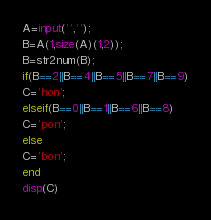Convert code to text. <code><loc_0><loc_0><loc_500><loc_500><_Octave_>A=input('','');
B=A(1,size(A)(1,2));
B=str2num(B);
if(B==2||B==4||B==5||B==7||B==9)
C='hon';
elseif(B==0||B==1||B==6||B==8)
C='pon';
else
C='bon';
end
disp(C)</code> 